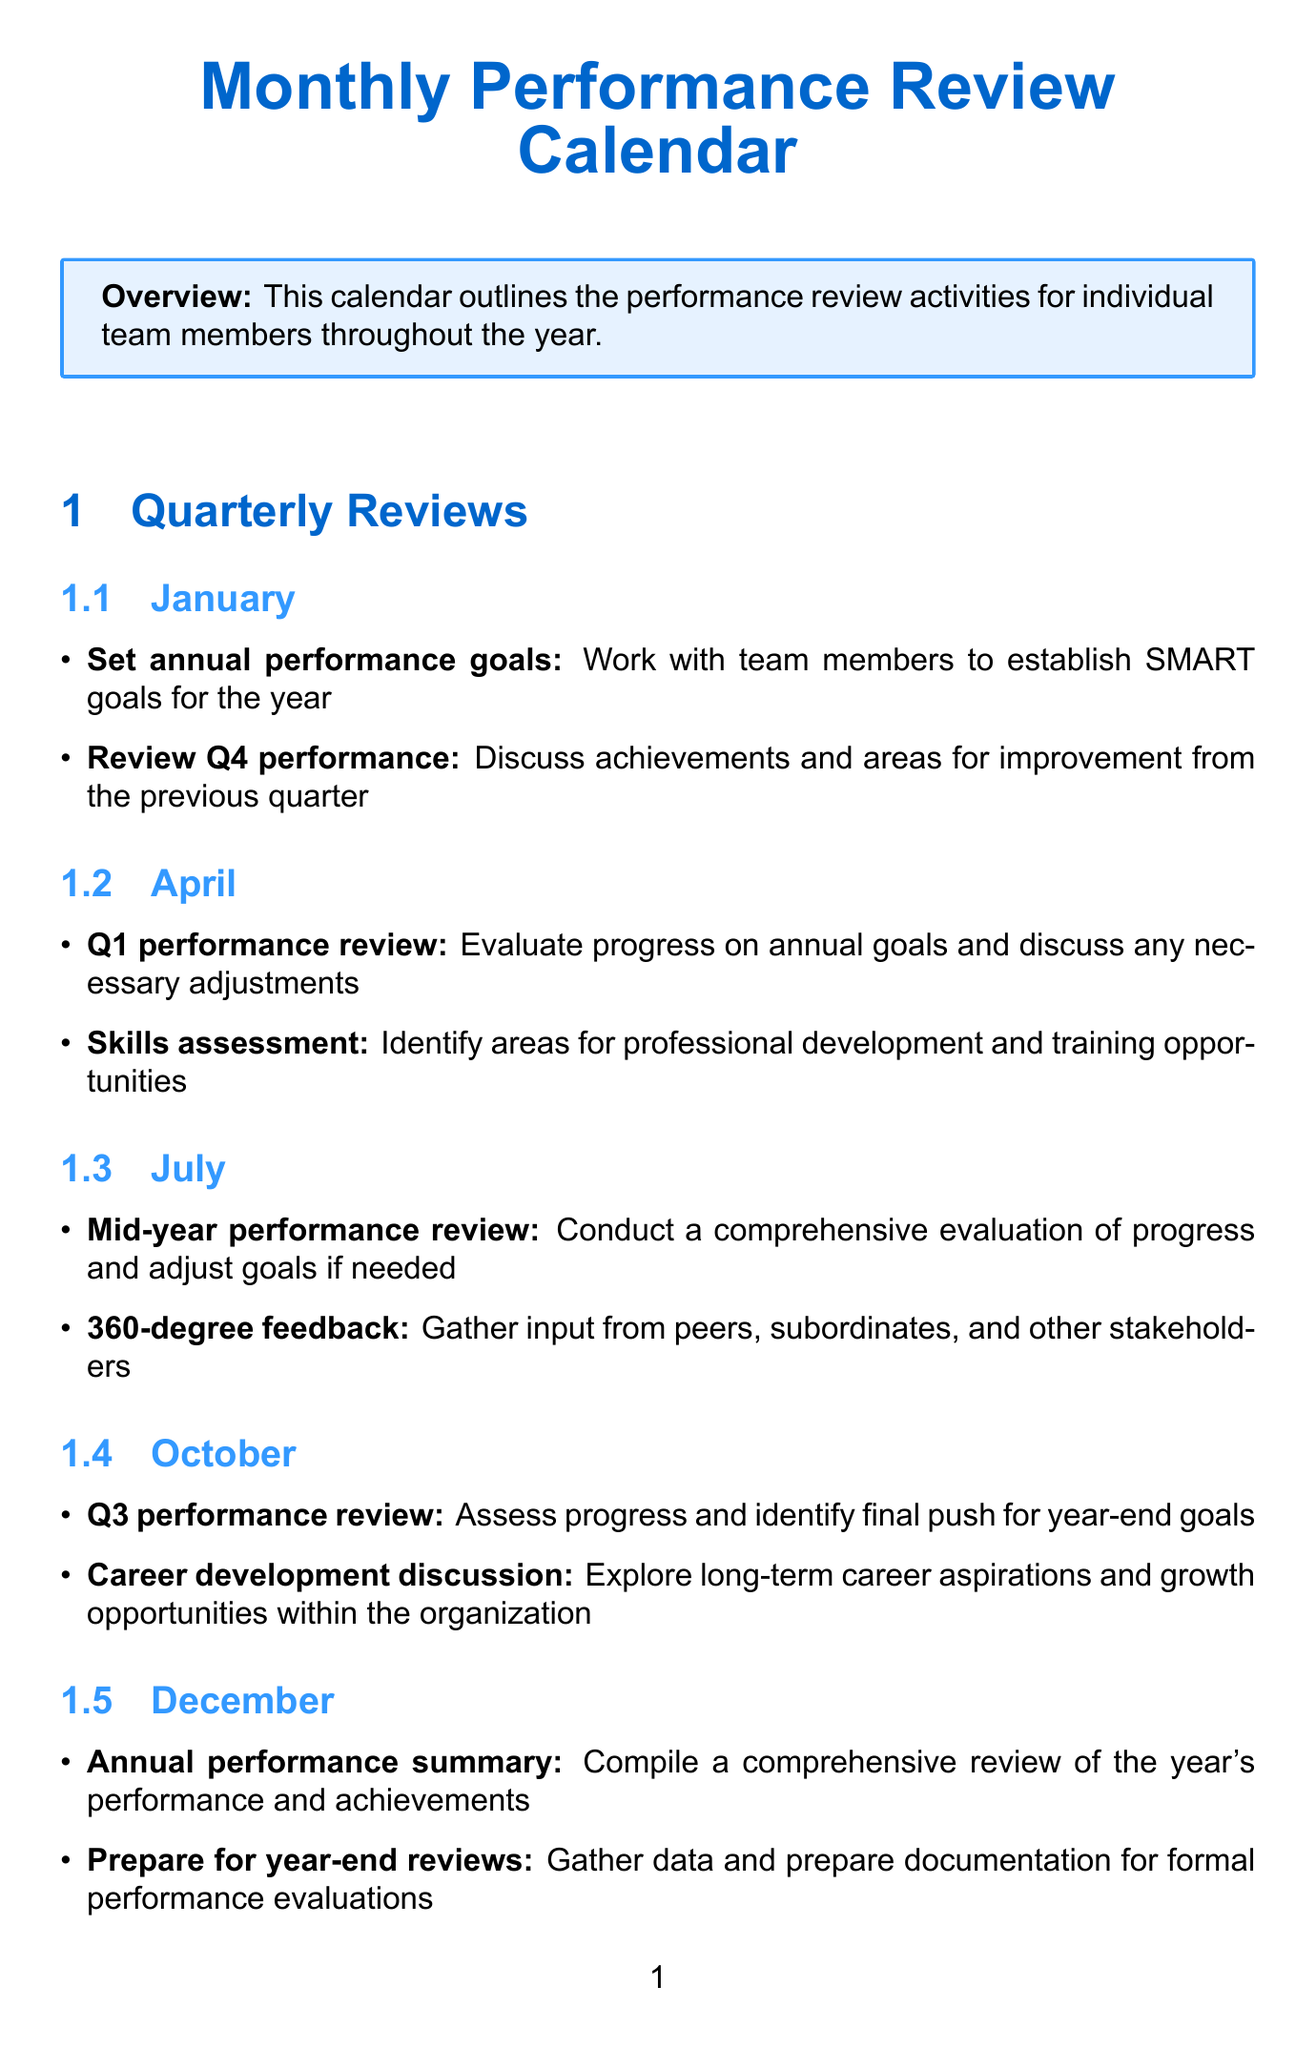What is the first activity listed in January? The first activity in January is to "Set annual performance goals."
Answer: Set annual performance goals Who participates in the Q1 performance review? The participants in the Q1 performance review are the Development Manager and Individual Team Members.
Answer: Development Manager, Individual Team Members Which month includes the "360-degree feedback" activity? The "360-degree feedback" activity is scheduled for July.
Answer: July How many activities are scheduled in October? There are two activities scheduled in October: "Q3 performance review" and "Career development discussion."
Answer: 2 What type of assessment is conducted in April? The activity in April aims for a "Skills assessment."
Answer: Skills assessment Who is involved in preparing for year-end reviews? The involved participants in preparing for year-end reviews are the Development Manager and HR Representative.
Answer: Development Manager, HR Representative What is the frequency of the Monthly one-on-ones? The frequency of the Monthly one-on-ones is defined as "Monthly."
Answer: Monthly What tool is used for tracking project progress? The tool used for tracking project progress is Jira.
Answer: Jira What happens in December related to performance? In December, an "Annual performance summary" is compiled.
Answer: Annual performance summary 